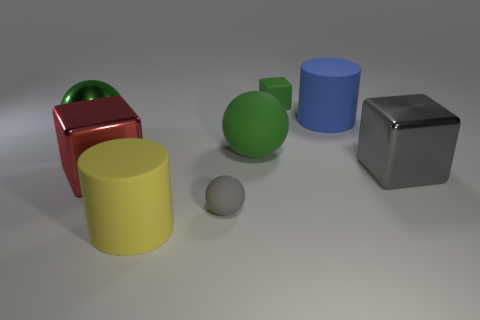Add 2 green metallic balls. How many objects exist? 10 Subtract all cylinders. How many objects are left? 6 Subtract all red cubes. Subtract all tiny green cubes. How many objects are left? 6 Add 2 large green metal balls. How many large green metal balls are left? 3 Add 7 large red objects. How many large red objects exist? 8 Subtract 1 gray cubes. How many objects are left? 7 